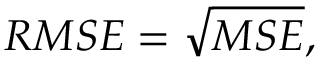Convert formula to latex. <formula><loc_0><loc_0><loc_500><loc_500>R M S E = \sqrt { M S E } ,</formula> 